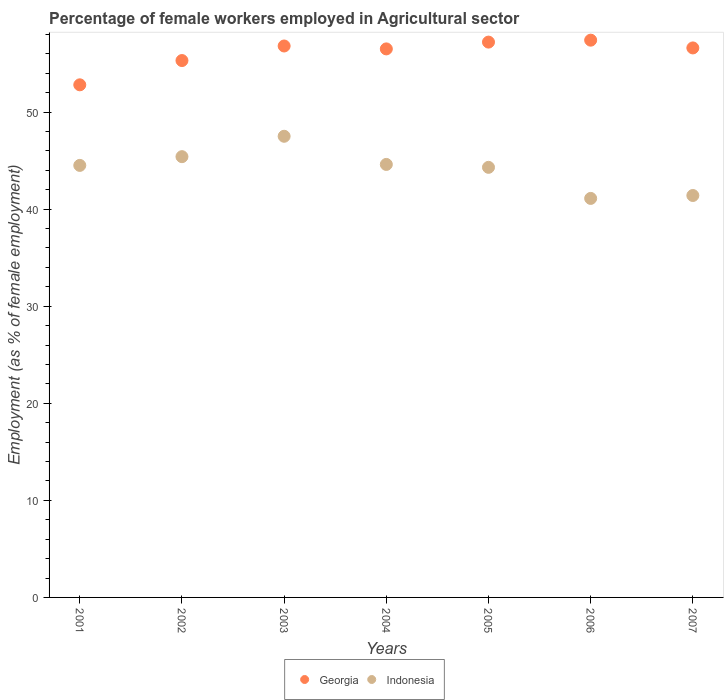What is the percentage of females employed in Agricultural sector in Georgia in 2001?
Make the answer very short. 52.8. Across all years, what is the maximum percentage of females employed in Agricultural sector in Indonesia?
Ensure brevity in your answer.  47.5. Across all years, what is the minimum percentage of females employed in Agricultural sector in Georgia?
Your answer should be very brief. 52.8. What is the total percentage of females employed in Agricultural sector in Georgia in the graph?
Your answer should be very brief. 392.6. What is the difference between the percentage of females employed in Agricultural sector in Indonesia in 2001 and that in 2005?
Offer a terse response. 0.2. What is the difference between the percentage of females employed in Agricultural sector in Indonesia in 2006 and the percentage of females employed in Agricultural sector in Georgia in 2001?
Your response must be concise. -11.7. What is the average percentage of females employed in Agricultural sector in Indonesia per year?
Your response must be concise. 44.11. In the year 2004, what is the difference between the percentage of females employed in Agricultural sector in Georgia and percentage of females employed in Agricultural sector in Indonesia?
Offer a very short reply. 11.9. In how many years, is the percentage of females employed in Agricultural sector in Georgia greater than 54 %?
Give a very brief answer. 6. What is the ratio of the percentage of females employed in Agricultural sector in Indonesia in 2002 to that in 2007?
Your answer should be very brief. 1.1. Is the percentage of females employed in Agricultural sector in Georgia in 2005 less than that in 2007?
Give a very brief answer. No. Is the difference between the percentage of females employed in Agricultural sector in Georgia in 2003 and 2004 greater than the difference between the percentage of females employed in Agricultural sector in Indonesia in 2003 and 2004?
Give a very brief answer. No. What is the difference between the highest and the second highest percentage of females employed in Agricultural sector in Georgia?
Your answer should be very brief. 0.2. What is the difference between the highest and the lowest percentage of females employed in Agricultural sector in Georgia?
Your answer should be very brief. 4.6. Is the percentage of females employed in Agricultural sector in Indonesia strictly less than the percentage of females employed in Agricultural sector in Georgia over the years?
Offer a terse response. Yes. Are the values on the major ticks of Y-axis written in scientific E-notation?
Your response must be concise. No. Where does the legend appear in the graph?
Ensure brevity in your answer.  Bottom center. How many legend labels are there?
Ensure brevity in your answer.  2. How are the legend labels stacked?
Provide a short and direct response. Horizontal. What is the title of the graph?
Offer a very short reply. Percentage of female workers employed in Agricultural sector. What is the label or title of the X-axis?
Keep it short and to the point. Years. What is the label or title of the Y-axis?
Give a very brief answer. Employment (as % of female employment). What is the Employment (as % of female employment) of Georgia in 2001?
Your answer should be very brief. 52.8. What is the Employment (as % of female employment) of Indonesia in 2001?
Offer a very short reply. 44.5. What is the Employment (as % of female employment) in Georgia in 2002?
Your response must be concise. 55.3. What is the Employment (as % of female employment) in Indonesia in 2002?
Provide a succinct answer. 45.4. What is the Employment (as % of female employment) in Georgia in 2003?
Make the answer very short. 56.8. What is the Employment (as % of female employment) in Indonesia in 2003?
Your response must be concise. 47.5. What is the Employment (as % of female employment) in Georgia in 2004?
Give a very brief answer. 56.5. What is the Employment (as % of female employment) in Indonesia in 2004?
Offer a terse response. 44.6. What is the Employment (as % of female employment) in Georgia in 2005?
Provide a short and direct response. 57.2. What is the Employment (as % of female employment) in Indonesia in 2005?
Provide a short and direct response. 44.3. What is the Employment (as % of female employment) in Georgia in 2006?
Your response must be concise. 57.4. What is the Employment (as % of female employment) of Indonesia in 2006?
Your answer should be very brief. 41.1. What is the Employment (as % of female employment) of Georgia in 2007?
Provide a short and direct response. 56.6. What is the Employment (as % of female employment) in Indonesia in 2007?
Give a very brief answer. 41.4. Across all years, what is the maximum Employment (as % of female employment) in Georgia?
Keep it short and to the point. 57.4. Across all years, what is the maximum Employment (as % of female employment) in Indonesia?
Provide a short and direct response. 47.5. Across all years, what is the minimum Employment (as % of female employment) in Georgia?
Your answer should be compact. 52.8. Across all years, what is the minimum Employment (as % of female employment) of Indonesia?
Ensure brevity in your answer.  41.1. What is the total Employment (as % of female employment) in Georgia in the graph?
Provide a succinct answer. 392.6. What is the total Employment (as % of female employment) in Indonesia in the graph?
Give a very brief answer. 308.8. What is the difference between the Employment (as % of female employment) of Georgia in 2001 and that in 2002?
Give a very brief answer. -2.5. What is the difference between the Employment (as % of female employment) in Georgia in 2001 and that in 2003?
Your response must be concise. -4. What is the difference between the Employment (as % of female employment) of Georgia in 2001 and that in 2004?
Provide a short and direct response. -3.7. What is the difference between the Employment (as % of female employment) of Georgia in 2001 and that in 2006?
Offer a very short reply. -4.6. What is the difference between the Employment (as % of female employment) in Indonesia in 2001 and that in 2006?
Keep it short and to the point. 3.4. What is the difference between the Employment (as % of female employment) in Georgia in 2001 and that in 2007?
Your answer should be very brief. -3.8. What is the difference between the Employment (as % of female employment) in Georgia in 2002 and that in 2003?
Your answer should be very brief. -1.5. What is the difference between the Employment (as % of female employment) in Indonesia in 2002 and that in 2004?
Offer a very short reply. 0.8. What is the difference between the Employment (as % of female employment) of Georgia in 2002 and that in 2005?
Your answer should be compact. -1.9. What is the difference between the Employment (as % of female employment) in Indonesia in 2002 and that in 2005?
Provide a succinct answer. 1.1. What is the difference between the Employment (as % of female employment) of Georgia in 2002 and that in 2007?
Offer a terse response. -1.3. What is the difference between the Employment (as % of female employment) in Georgia in 2003 and that in 2004?
Provide a succinct answer. 0.3. What is the difference between the Employment (as % of female employment) in Indonesia in 2003 and that in 2004?
Ensure brevity in your answer.  2.9. What is the difference between the Employment (as % of female employment) of Georgia in 2003 and that in 2005?
Make the answer very short. -0.4. What is the difference between the Employment (as % of female employment) in Indonesia in 2004 and that in 2005?
Your answer should be very brief. 0.3. What is the difference between the Employment (as % of female employment) of Georgia in 2004 and that in 2006?
Keep it short and to the point. -0.9. What is the difference between the Employment (as % of female employment) in Indonesia in 2005 and that in 2006?
Your response must be concise. 3.2. What is the difference between the Employment (as % of female employment) in Georgia in 2006 and that in 2007?
Offer a very short reply. 0.8. What is the difference between the Employment (as % of female employment) of Indonesia in 2006 and that in 2007?
Your answer should be compact. -0.3. What is the difference between the Employment (as % of female employment) of Georgia in 2001 and the Employment (as % of female employment) of Indonesia in 2004?
Your response must be concise. 8.2. What is the difference between the Employment (as % of female employment) of Georgia in 2001 and the Employment (as % of female employment) of Indonesia in 2006?
Offer a very short reply. 11.7. What is the difference between the Employment (as % of female employment) of Georgia in 2002 and the Employment (as % of female employment) of Indonesia in 2003?
Provide a succinct answer. 7.8. What is the difference between the Employment (as % of female employment) of Georgia in 2002 and the Employment (as % of female employment) of Indonesia in 2004?
Your answer should be very brief. 10.7. What is the difference between the Employment (as % of female employment) of Georgia in 2002 and the Employment (as % of female employment) of Indonesia in 2005?
Your response must be concise. 11. What is the difference between the Employment (as % of female employment) in Georgia in 2002 and the Employment (as % of female employment) in Indonesia in 2007?
Provide a succinct answer. 13.9. What is the difference between the Employment (as % of female employment) of Georgia in 2003 and the Employment (as % of female employment) of Indonesia in 2004?
Offer a terse response. 12.2. What is the difference between the Employment (as % of female employment) of Georgia in 2003 and the Employment (as % of female employment) of Indonesia in 2005?
Provide a succinct answer. 12.5. What is the difference between the Employment (as % of female employment) in Georgia in 2003 and the Employment (as % of female employment) in Indonesia in 2007?
Your response must be concise. 15.4. What is the difference between the Employment (as % of female employment) of Georgia in 2005 and the Employment (as % of female employment) of Indonesia in 2006?
Keep it short and to the point. 16.1. What is the difference between the Employment (as % of female employment) of Georgia in 2005 and the Employment (as % of female employment) of Indonesia in 2007?
Make the answer very short. 15.8. What is the average Employment (as % of female employment) of Georgia per year?
Offer a terse response. 56.09. What is the average Employment (as % of female employment) of Indonesia per year?
Offer a terse response. 44.11. In the year 2002, what is the difference between the Employment (as % of female employment) in Georgia and Employment (as % of female employment) in Indonesia?
Offer a very short reply. 9.9. In the year 2003, what is the difference between the Employment (as % of female employment) in Georgia and Employment (as % of female employment) in Indonesia?
Keep it short and to the point. 9.3. In the year 2004, what is the difference between the Employment (as % of female employment) in Georgia and Employment (as % of female employment) in Indonesia?
Provide a succinct answer. 11.9. In the year 2006, what is the difference between the Employment (as % of female employment) in Georgia and Employment (as % of female employment) in Indonesia?
Ensure brevity in your answer.  16.3. What is the ratio of the Employment (as % of female employment) of Georgia in 2001 to that in 2002?
Make the answer very short. 0.95. What is the ratio of the Employment (as % of female employment) of Indonesia in 2001 to that in 2002?
Your answer should be compact. 0.98. What is the ratio of the Employment (as % of female employment) of Georgia in 2001 to that in 2003?
Keep it short and to the point. 0.93. What is the ratio of the Employment (as % of female employment) in Indonesia in 2001 to that in 2003?
Offer a very short reply. 0.94. What is the ratio of the Employment (as % of female employment) of Georgia in 2001 to that in 2004?
Offer a very short reply. 0.93. What is the ratio of the Employment (as % of female employment) in Indonesia in 2001 to that in 2004?
Provide a succinct answer. 1. What is the ratio of the Employment (as % of female employment) in Indonesia in 2001 to that in 2005?
Provide a short and direct response. 1. What is the ratio of the Employment (as % of female employment) in Georgia in 2001 to that in 2006?
Your answer should be compact. 0.92. What is the ratio of the Employment (as % of female employment) in Indonesia in 2001 to that in 2006?
Your answer should be very brief. 1.08. What is the ratio of the Employment (as % of female employment) of Georgia in 2001 to that in 2007?
Make the answer very short. 0.93. What is the ratio of the Employment (as % of female employment) in Indonesia in 2001 to that in 2007?
Your response must be concise. 1.07. What is the ratio of the Employment (as % of female employment) in Georgia in 2002 to that in 2003?
Ensure brevity in your answer.  0.97. What is the ratio of the Employment (as % of female employment) of Indonesia in 2002 to that in 2003?
Provide a succinct answer. 0.96. What is the ratio of the Employment (as % of female employment) of Georgia in 2002 to that in 2004?
Your answer should be compact. 0.98. What is the ratio of the Employment (as % of female employment) of Indonesia in 2002 to that in 2004?
Provide a succinct answer. 1.02. What is the ratio of the Employment (as % of female employment) in Georgia in 2002 to that in 2005?
Keep it short and to the point. 0.97. What is the ratio of the Employment (as % of female employment) of Indonesia in 2002 to that in 2005?
Keep it short and to the point. 1.02. What is the ratio of the Employment (as % of female employment) in Georgia in 2002 to that in 2006?
Keep it short and to the point. 0.96. What is the ratio of the Employment (as % of female employment) in Indonesia in 2002 to that in 2006?
Your response must be concise. 1.1. What is the ratio of the Employment (as % of female employment) of Georgia in 2002 to that in 2007?
Make the answer very short. 0.98. What is the ratio of the Employment (as % of female employment) of Indonesia in 2002 to that in 2007?
Your response must be concise. 1.1. What is the ratio of the Employment (as % of female employment) of Georgia in 2003 to that in 2004?
Your answer should be very brief. 1.01. What is the ratio of the Employment (as % of female employment) of Indonesia in 2003 to that in 2004?
Keep it short and to the point. 1.06. What is the ratio of the Employment (as % of female employment) in Georgia in 2003 to that in 2005?
Provide a short and direct response. 0.99. What is the ratio of the Employment (as % of female employment) of Indonesia in 2003 to that in 2005?
Give a very brief answer. 1.07. What is the ratio of the Employment (as % of female employment) in Georgia in 2003 to that in 2006?
Your answer should be very brief. 0.99. What is the ratio of the Employment (as % of female employment) of Indonesia in 2003 to that in 2006?
Your answer should be compact. 1.16. What is the ratio of the Employment (as % of female employment) in Georgia in 2003 to that in 2007?
Offer a terse response. 1. What is the ratio of the Employment (as % of female employment) of Indonesia in 2003 to that in 2007?
Provide a short and direct response. 1.15. What is the ratio of the Employment (as % of female employment) in Indonesia in 2004 to that in 2005?
Your response must be concise. 1.01. What is the ratio of the Employment (as % of female employment) in Georgia in 2004 to that in 2006?
Keep it short and to the point. 0.98. What is the ratio of the Employment (as % of female employment) in Indonesia in 2004 to that in 2006?
Give a very brief answer. 1.09. What is the ratio of the Employment (as % of female employment) in Georgia in 2004 to that in 2007?
Provide a short and direct response. 1. What is the ratio of the Employment (as % of female employment) of Indonesia in 2004 to that in 2007?
Provide a short and direct response. 1.08. What is the ratio of the Employment (as % of female employment) in Georgia in 2005 to that in 2006?
Provide a short and direct response. 1. What is the ratio of the Employment (as % of female employment) in Indonesia in 2005 to that in 2006?
Keep it short and to the point. 1.08. What is the ratio of the Employment (as % of female employment) in Georgia in 2005 to that in 2007?
Ensure brevity in your answer.  1.01. What is the ratio of the Employment (as % of female employment) of Indonesia in 2005 to that in 2007?
Keep it short and to the point. 1.07. What is the ratio of the Employment (as % of female employment) in Georgia in 2006 to that in 2007?
Provide a succinct answer. 1.01. What is the ratio of the Employment (as % of female employment) in Indonesia in 2006 to that in 2007?
Provide a succinct answer. 0.99. What is the difference between the highest and the second highest Employment (as % of female employment) of Indonesia?
Your response must be concise. 2.1. 